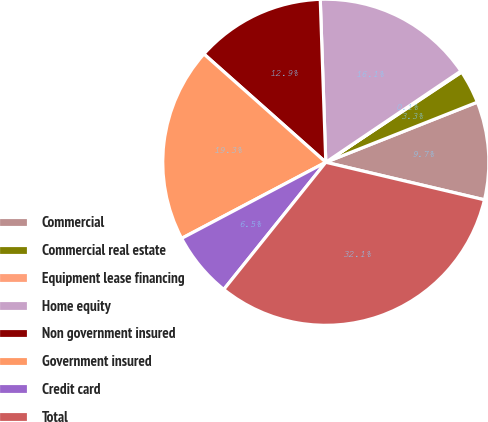<chart> <loc_0><loc_0><loc_500><loc_500><pie_chart><fcel>Commercial<fcel>Commercial real estate<fcel>Equipment lease financing<fcel>Home equity<fcel>Non government insured<fcel>Government insured<fcel>Credit card<fcel>Total<nl><fcel>9.71%<fcel>3.32%<fcel>0.12%<fcel>16.09%<fcel>12.9%<fcel>19.29%<fcel>6.51%<fcel>32.06%<nl></chart> 